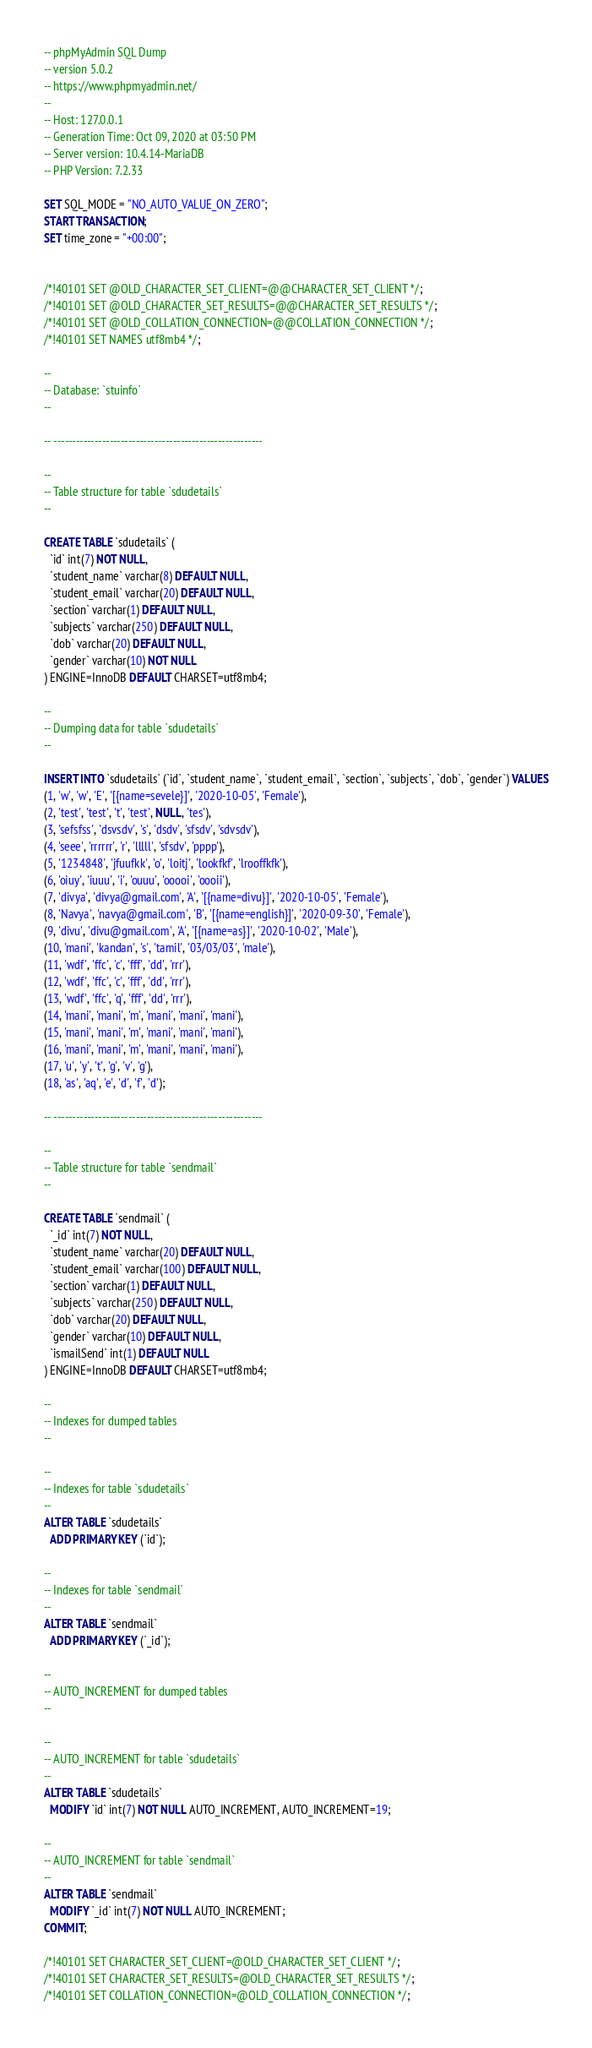<code> <loc_0><loc_0><loc_500><loc_500><_SQL_>-- phpMyAdmin SQL Dump
-- version 5.0.2
-- https://www.phpmyadmin.net/
--
-- Host: 127.0.0.1
-- Generation Time: Oct 09, 2020 at 03:50 PM
-- Server version: 10.4.14-MariaDB
-- PHP Version: 7.2.33

SET SQL_MODE = "NO_AUTO_VALUE_ON_ZERO";
START TRANSACTION;
SET time_zone = "+00:00";


/*!40101 SET @OLD_CHARACTER_SET_CLIENT=@@CHARACTER_SET_CLIENT */;
/*!40101 SET @OLD_CHARACTER_SET_RESULTS=@@CHARACTER_SET_RESULTS */;
/*!40101 SET @OLD_COLLATION_CONNECTION=@@COLLATION_CONNECTION */;
/*!40101 SET NAMES utf8mb4 */;

--
-- Database: `stuinfo`
--

-- --------------------------------------------------------

--
-- Table structure for table `sdudetails`
--

CREATE TABLE `sdudetails` (
  `id` int(7) NOT NULL,
  `student_name` varchar(8) DEFAULT NULL,
  `student_email` varchar(20) DEFAULT NULL,
  `section` varchar(1) DEFAULT NULL,
  `subjects` varchar(250) DEFAULT NULL,
  `dob` varchar(20) DEFAULT NULL,
  `gender` varchar(10) NOT NULL
) ENGINE=InnoDB DEFAULT CHARSET=utf8mb4;

--
-- Dumping data for table `sdudetails`
--

INSERT INTO `sdudetails` (`id`, `student_name`, `student_email`, `section`, `subjects`, `dob`, `gender`) VALUES
(1, 'w', 'w', 'E', '[{name=sevele}]', '2020-10-05', 'Female'),
(2, 'test', 'test', 't', 'test', NULL, 'tes'),
(3, 'sefsfss', 'dsvsdv', 's', 'dsdv', 'sfsdv', 'sdvsdv'),
(4, 'seee', 'rrrrrr', 'r', 'lllll', 'sfsdv', 'pppp'),
(5, '1234848', 'jfuufkk', 'o', 'loitj', 'lookfkf', 'lrooffkfk'),
(6, 'oiuy', 'iuuu', 'i', 'ouuu', 'ooooi', 'oooii'),
(7, 'divya', 'divya@gmail.com', 'A', '[{name=divu}]', '2020-10-05', 'Female'),
(8, 'Navya', 'navya@gmail.com', 'B', '[{name=english}]', '2020-09-30', 'Female'),
(9, 'divu', 'divu@gmail.com', 'A', '[{name=as}]', '2020-10-02', 'Male'),
(10, 'mani', 'kandan', 's', 'tamil', '03/03/03', 'male'),
(11, 'wdf', 'ffc', 'c', 'fff', 'dd', 'rrr'),
(12, 'wdf', 'ffc', 'c', 'fff', 'dd', 'rrr'),
(13, 'wdf', 'ffc', 'q', 'fff', 'dd', 'rrr'),
(14, 'mani', 'mani', 'm', 'mani', 'mani', 'mani'),
(15, 'mani', 'mani', 'm', 'mani', 'mani', 'mani'),
(16, 'mani', 'mani', 'm', 'mani', 'mani', 'mani'),
(17, 'u', 'y', 't', 'g', 'v', 'g'),
(18, 'as', 'aq', 'e', 'd', 'f', 'd');

-- --------------------------------------------------------

--
-- Table structure for table `sendmail`
--

CREATE TABLE `sendmail` (
  `_id` int(7) NOT NULL,
  `student_name` varchar(20) DEFAULT NULL,
  `student_email` varchar(100) DEFAULT NULL,
  `section` varchar(1) DEFAULT NULL,
  `subjects` varchar(250) DEFAULT NULL,
  `dob` varchar(20) DEFAULT NULL,
  `gender` varchar(10) DEFAULT NULL,
  `ismailSend` int(1) DEFAULT NULL
) ENGINE=InnoDB DEFAULT CHARSET=utf8mb4;

--
-- Indexes for dumped tables
--

--
-- Indexes for table `sdudetails`
--
ALTER TABLE `sdudetails`
  ADD PRIMARY KEY (`id`);

--
-- Indexes for table `sendmail`
--
ALTER TABLE `sendmail`
  ADD PRIMARY KEY (`_id`);

--
-- AUTO_INCREMENT for dumped tables
--

--
-- AUTO_INCREMENT for table `sdudetails`
--
ALTER TABLE `sdudetails`
  MODIFY `id` int(7) NOT NULL AUTO_INCREMENT, AUTO_INCREMENT=19;

--
-- AUTO_INCREMENT for table `sendmail`
--
ALTER TABLE `sendmail`
  MODIFY `_id` int(7) NOT NULL AUTO_INCREMENT;
COMMIT;

/*!40101 SET CHARACTER_SET_CLIENT=@OLD_CHARACTER_SET_CLIENT */;
/*!40101 SET CHARACTER_SET_RESULTS=@OLD_CHARACTER_SET_RESULTS */;
/*!40101 SET COLLATION_CONNECTION=@OLD_COLLATION_CONNECTION */;
</code> 